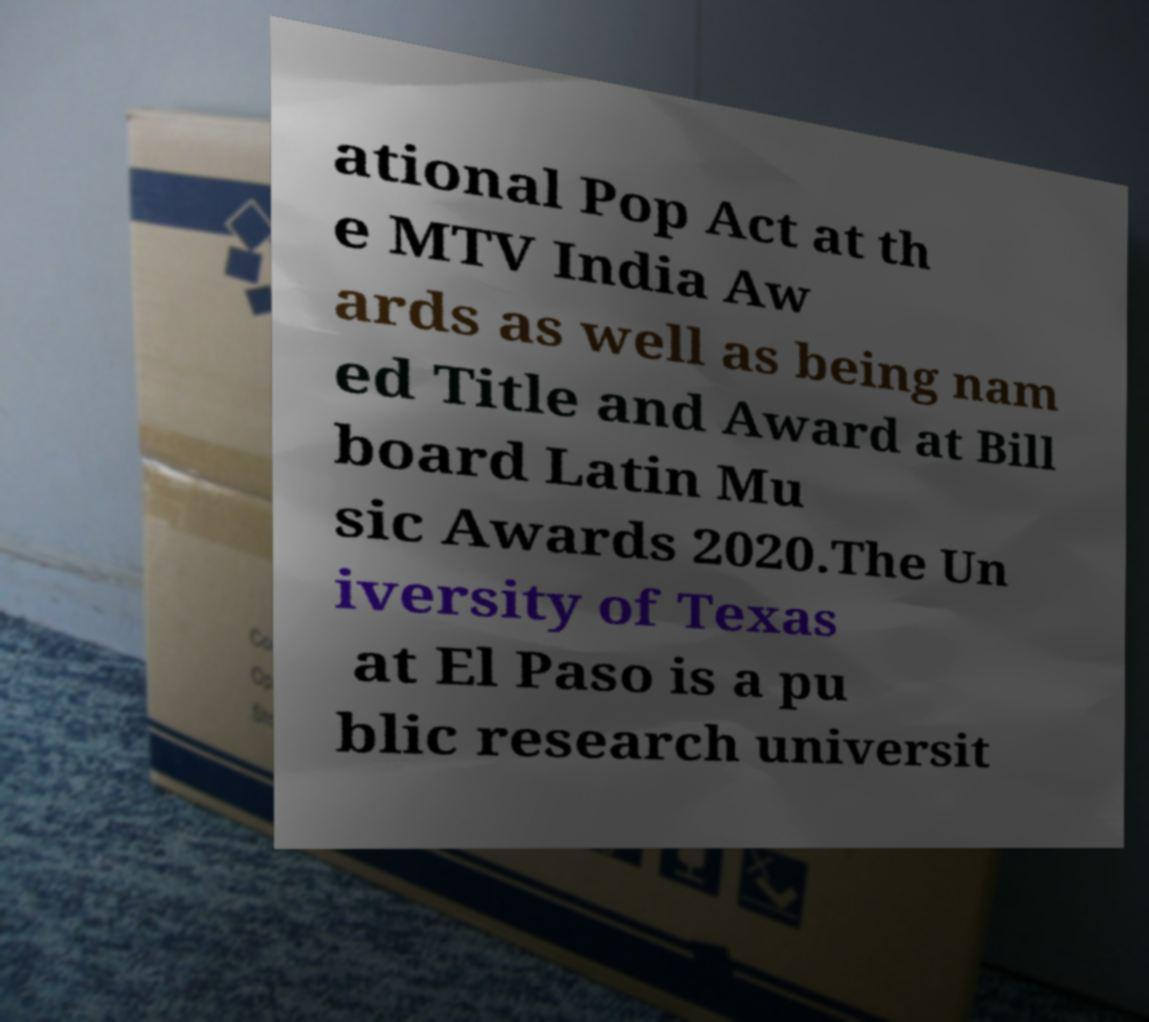Could you assist in decoding the text presented in this image and type it out clearly? ational Pop Act at th e MTV India Aw ards as well as being nam ed Title and Award at Bill board Latin Mu sic Awards 2020.The Un iversity of Texas at El Paso is a pu blic research universit 